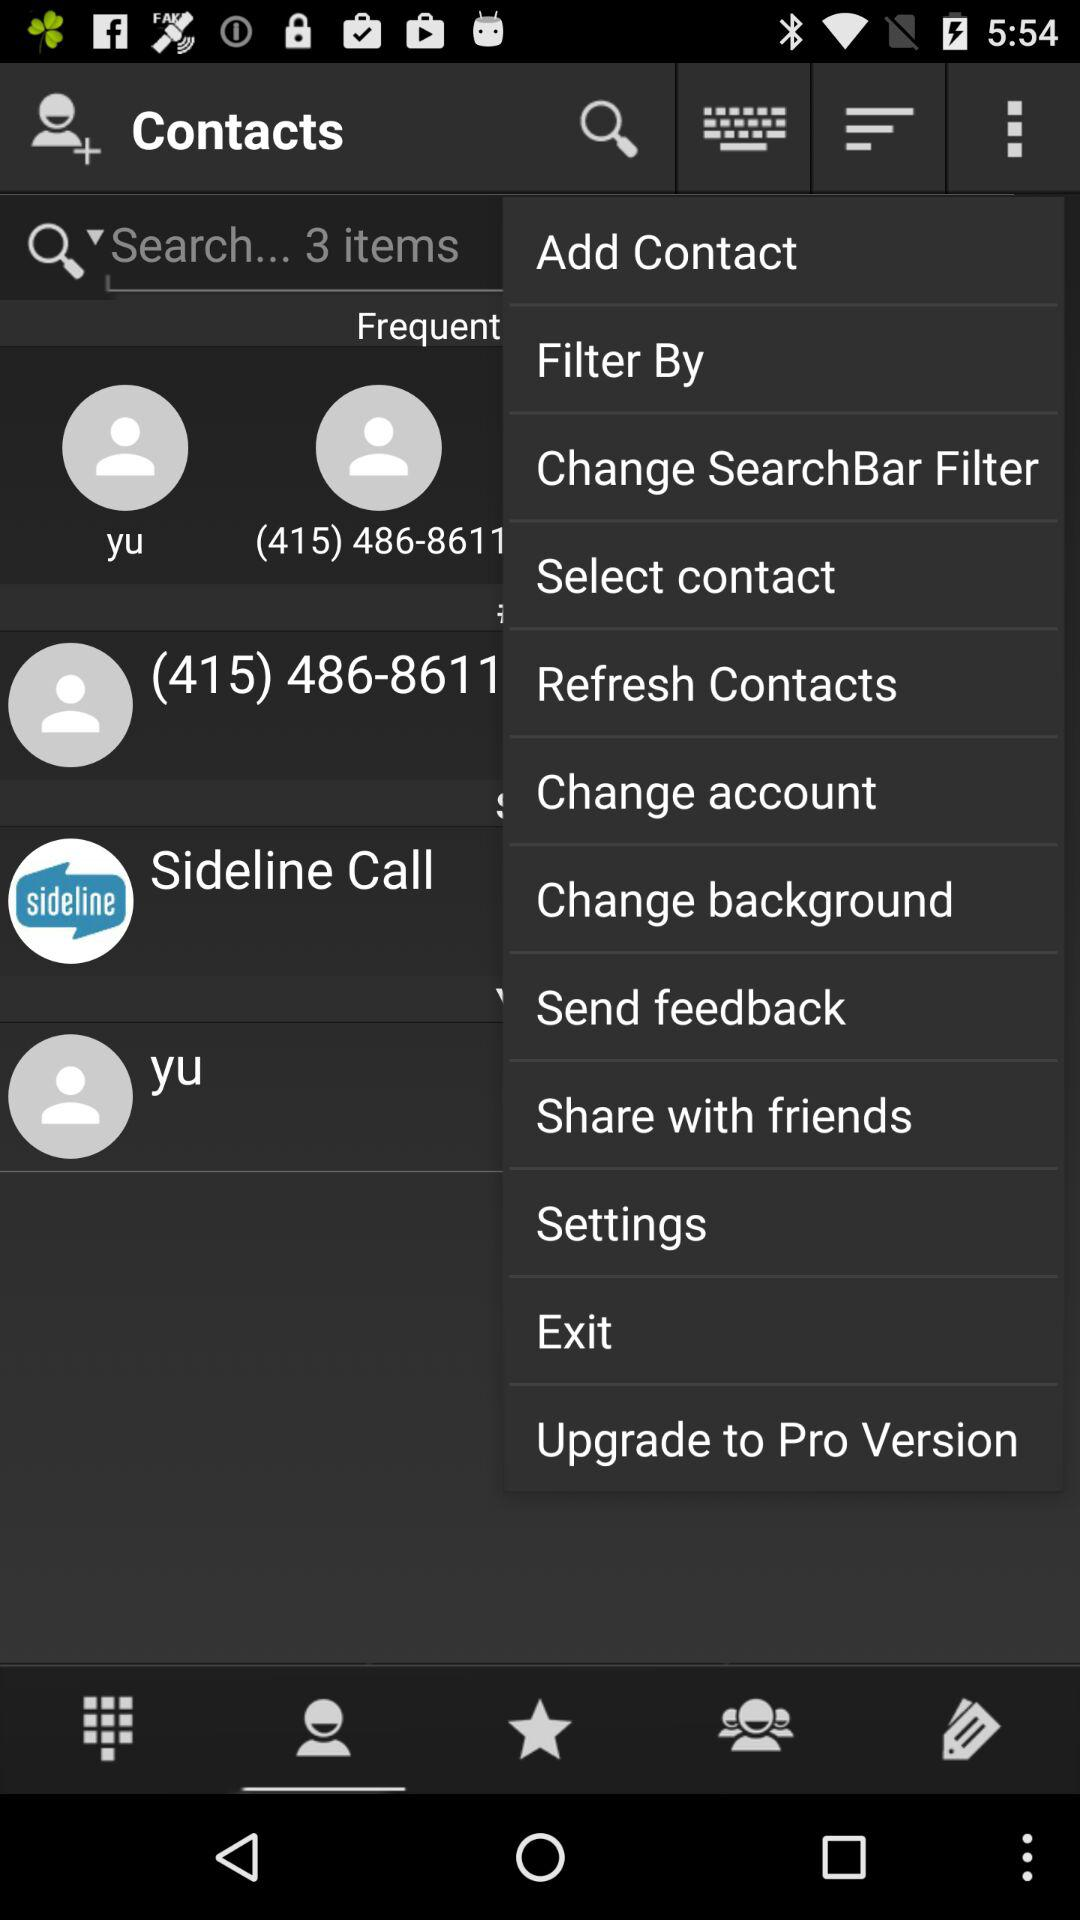Which tab is selected? The selected tab is "Contacts". 